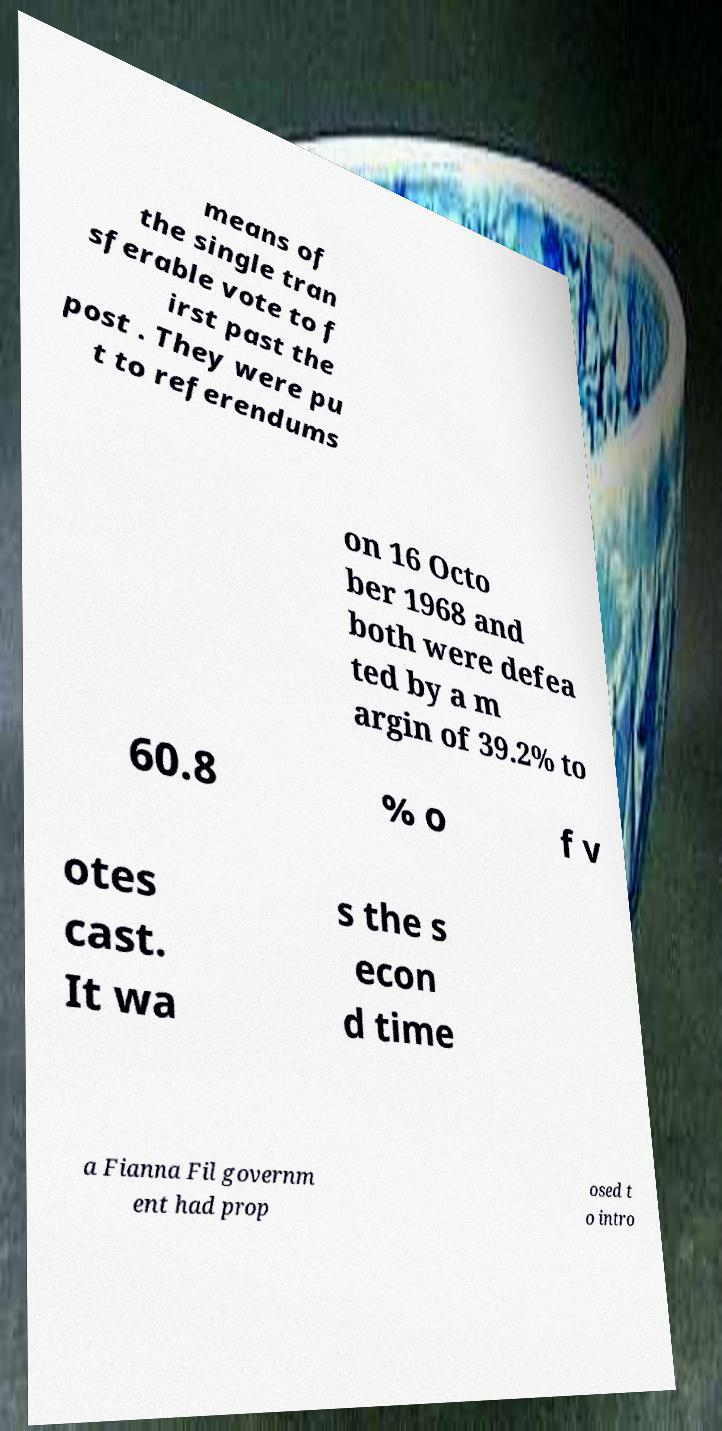There's text embedded in this image that I need extracted. Can you transcribe it verbatim? means of the single tran sferable vote to f irst past the post . They were pu t to referendums on 16 Octo ber 1968 and both were defea ted by a m argin of 39.2% to 60.8 % o f v otes cast. It wa s the s econ d time a Fianna Fil governm ent had prop osed t o intro 